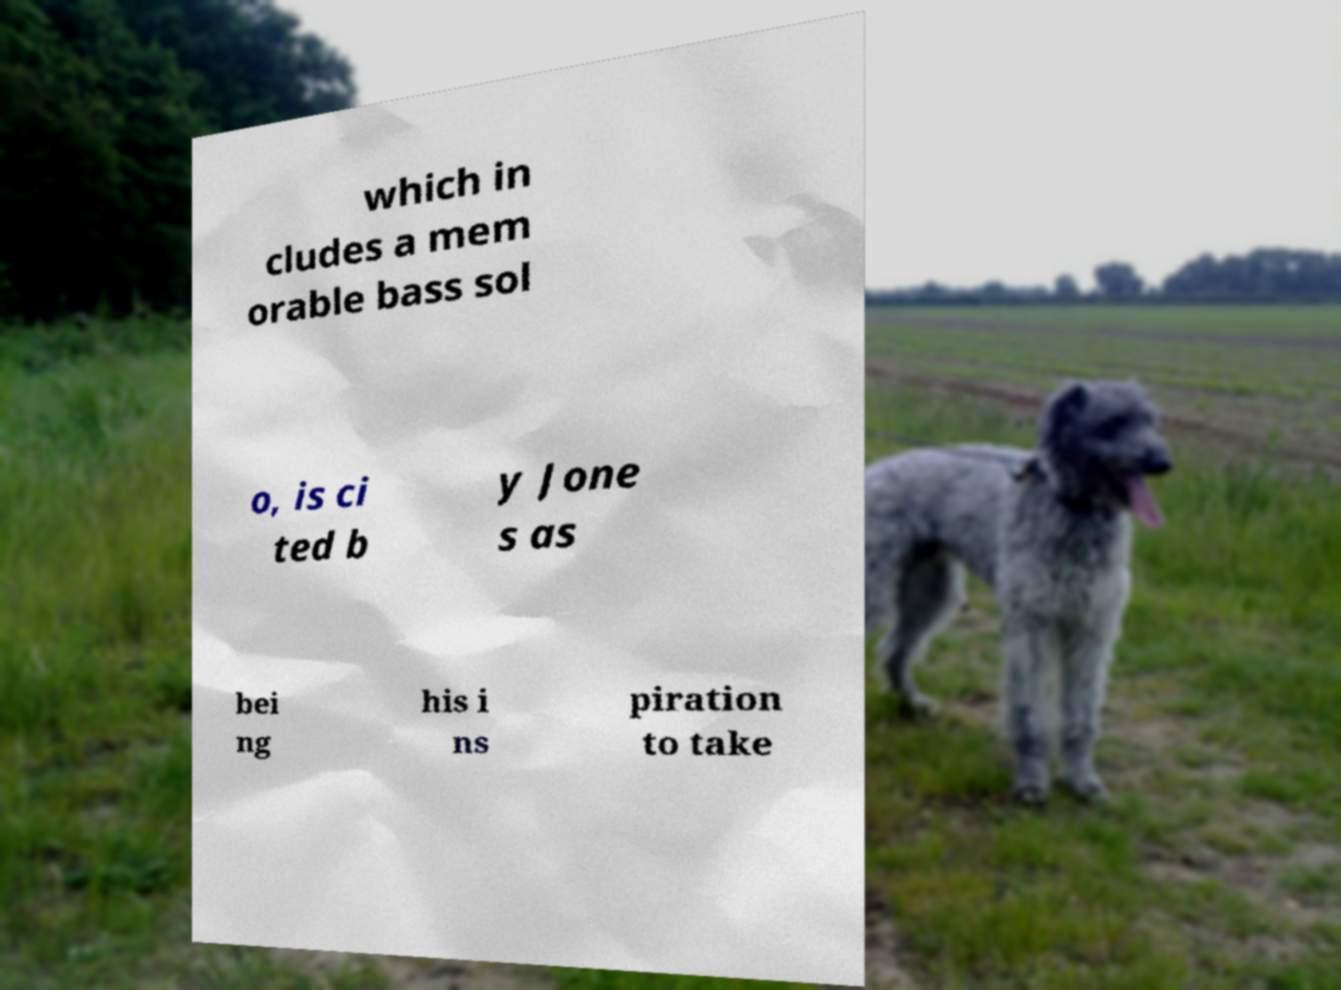Please identify and transcribe the text found in this image. which in cludes a mem orable bass sol o, is ci ted b y Jone s as bei ng his i ns piration to take 